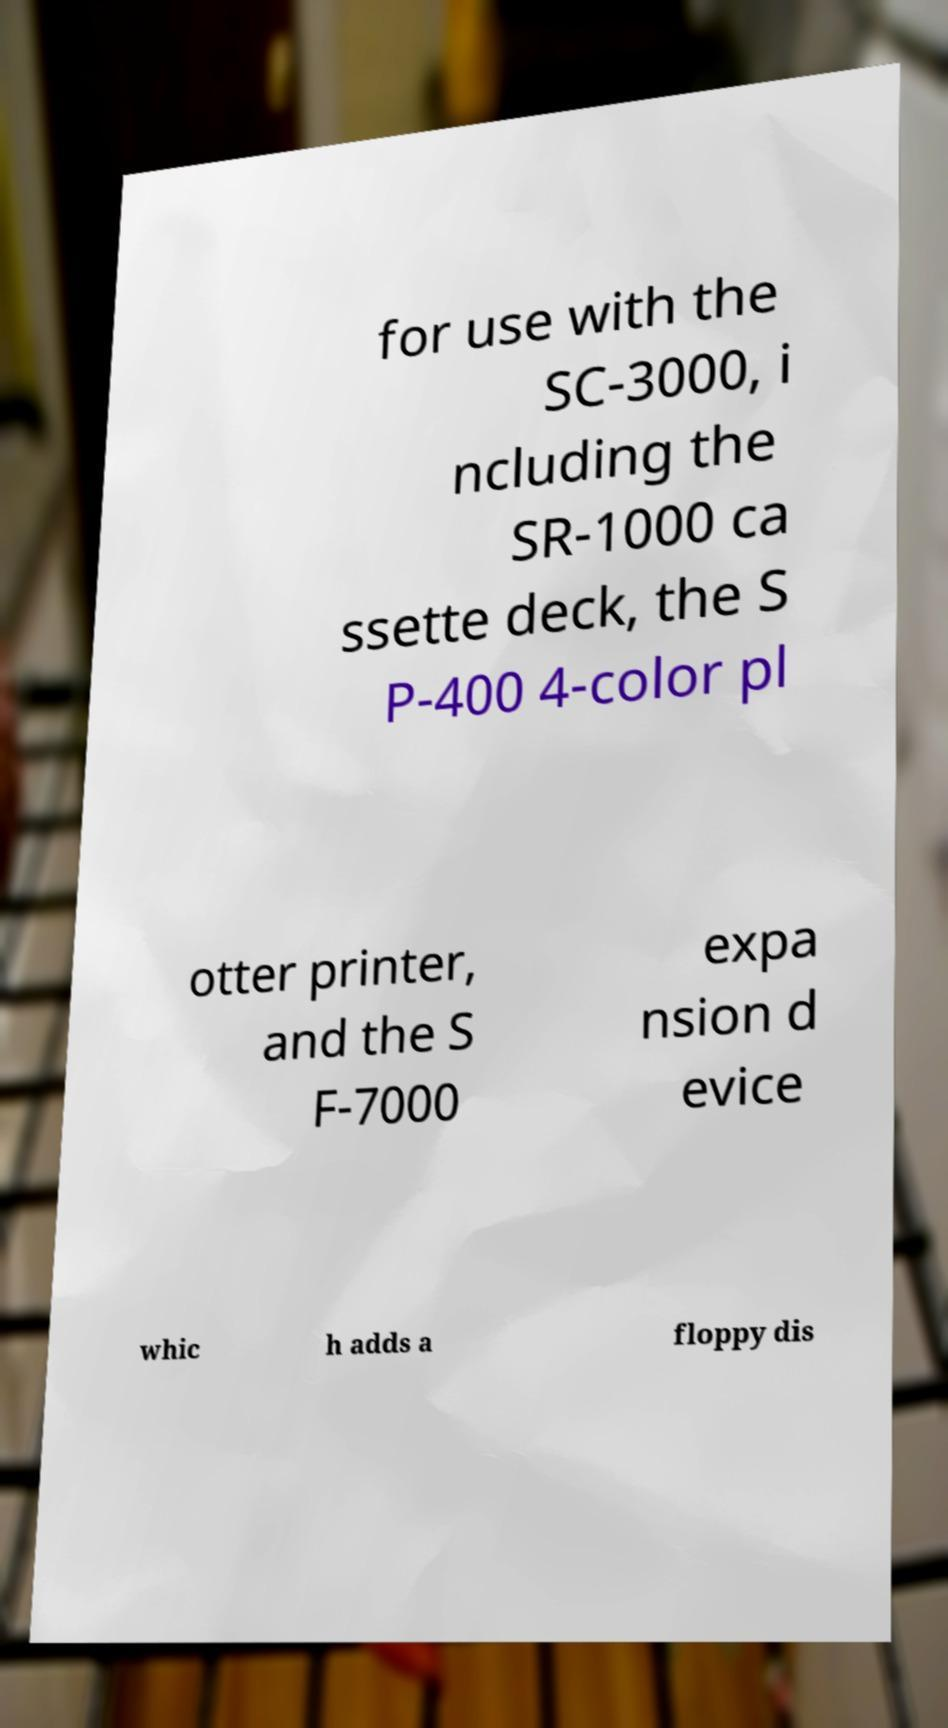Can you read and provide the text displayed in the image?This photo seems to have some interesting text. Can you extract and type it out for me? for use with the SC-3000, i ncluding the SR-1000 ca ssette deck, the S P-400 4-color pl otter printer, and the S F-7000 expa nsion d evice whic h adds a floppy dis 